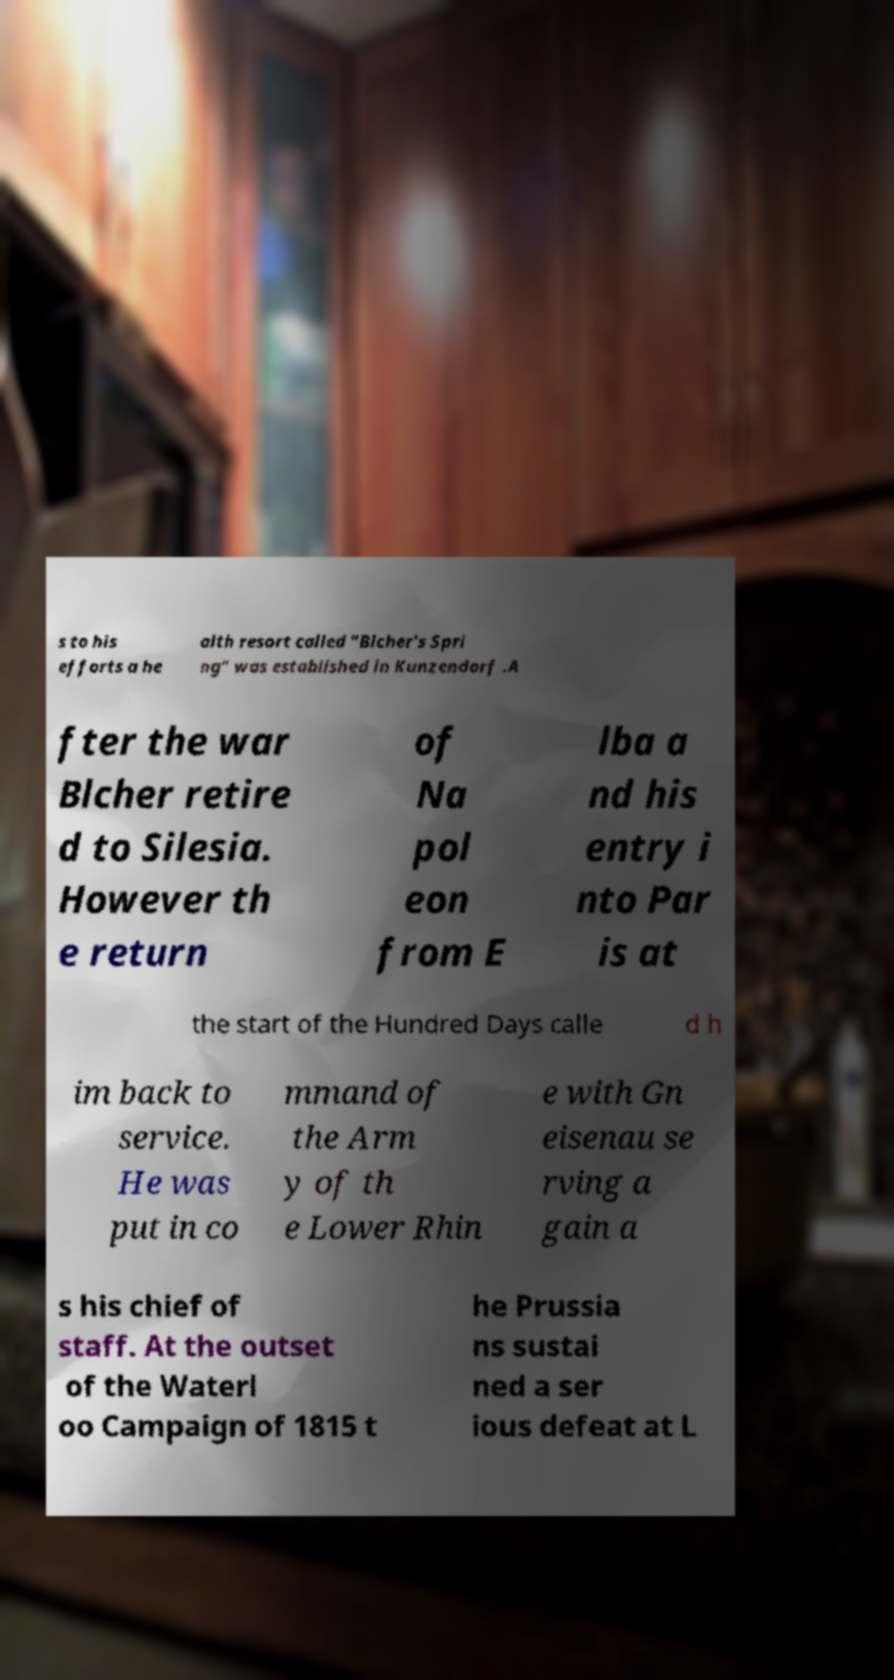What messages or text are displayed in this image? I need them in a readable, typed format. s to his efforts a he alth resort called "Blcher's Spri ng" was established in Kunzendorf .A fter the war Blcher retire d to Silesia. However th e return of Na pol eon from E lba a nd his entry i nto Par is at the start of the Hundred Days calle d h im back to service. He was put in co mmand of the Arm y of th e Lower Rhin e with Gn eisenau se rving a gain a s his chief of staff. At the outset of the Waterl oo Campaign of 1815 t he Prussia ns sustai ned a ser ious defeat at L 